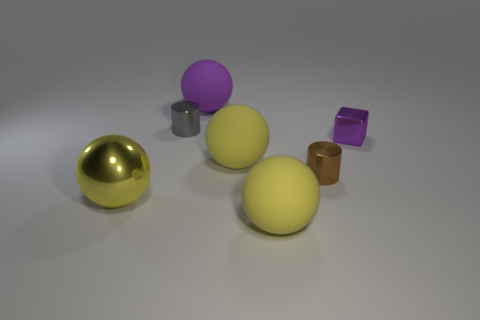There is a tiny object that is behind the small brown object and right of the purple rubber object; what shape is it?
Your response must be concise. Cube. How big is the yellow object that is to the left of the large yellow thing behind the big shiny thing?
Provide a short and direct response. Large. What number of other objects are there of the same color as the metallic sphere?
Your answer should be compact. 2. What is the material of the small brown thing?
Your answer should be compact. Metal. Are any shiny spheres visible?
Provide a succinct answer. Yes. Are there an equal number of matte objects that are in front of the purple block and yellow balls?
Make the answer very short. No. Are there any other things that have the same material as the tiny brown thing?
Your answer should be very brief. Yes. How many big things are either green cylinders or matte spheres?
Offer a very short reply. 3. Is the material of the big yellow thing behind the small brown shiny object the same as the gray cylinder?
Ensure brevity in your answer.  No. There is a purple object behind the shiny cylinder on the left side of the purple ball; what is its material?
Provide a short and direct response. Rubber. 